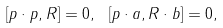<formula> <loc_0><loc_0><loc_500><loc_500>[ p \cdot p , R ] = 0 , \ [ p \cdot a , R \cdot b ] = 0 ,</formula> 